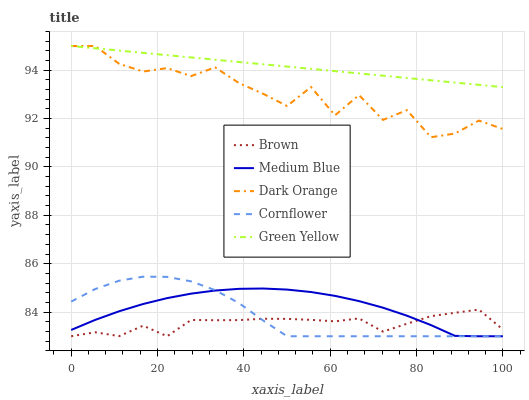Does Brown have the minimum area under the curve?
Answer yes or no. Yes. Does Green Yellow have the maximum area under the curve?
Answer yes or no. Yes. Does Medium Blue have the minimum area under the curve?
Answer yes or no. No. Does Medium Blue have the maximum area under the curve?
Answer yes or no. No. Is Green Yellow the smoothest?
Answer yes or no. Yes. Is Dark Orange the roughest?
Answer yes or no. Yes. Is Medium Blue the smoothest?
Answer yes or no. No. Is Medium Blue the roughest?
Answer yes or no. No. Does Brown have the lowest value?
Answer yes or no. Yes. Does Green Yellow have the lowest value?
Answer yes or no. No. Does Dark Orange have the highest value?
Answer yes or no. Yes. Does Medium Blue have the highest value?
Answer yes or no. No. Is Cornflower less than Dark Orange?
Answer yes or no. Yes. Is Dark Orange greater than Cornflower?
Answer yes or no. Yes. Does Cornflower intersect Brown?
Answer yes or no. Yes. Is Cornflower less than Brown?
Answer yes or no. No. Is Cornflower greater than Brown?
Answer yes or no. No. Does Cornflower intersect Dark Orange?
Answer yes or no. No. 